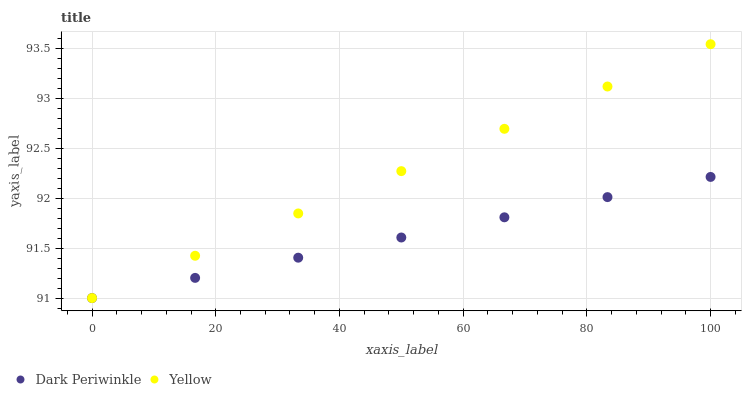Does Dark Periwinkle have the minimum area under the curve?
Answer yes or no. Yes. Does Yellow have the maximum area under the curve?
Answer yes or no. Yes. Does Yellow have the minimum area under the curve?
Answer yes or no. No. Is Dark Periwinkle the smoothest?
Answer yes or no. Yes. Is Yellow the roughest?
Answer yes or no. Yes. Is Yellow the smoothest?
Answer yes or no. No. Does Dark Periwinkle have the lowest value?
Answer yes or no. Yes. Does Yellow have the highest value?
Answer yes or no. Yes. Does Yellow intersect Dark Periwinkle?
Answer yes or no. Yes. Is Yellow less than Dark Periwinkle?
Answer yes or no. No. Is Yellow greater than Dark Periwinkle?
Answer yes or no. No. 